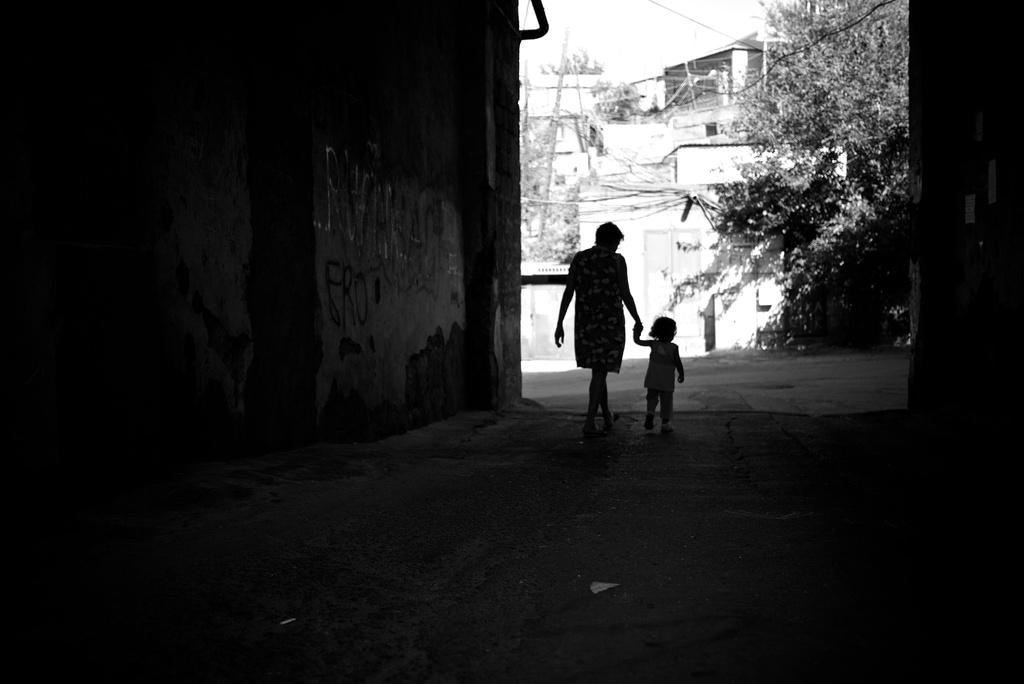Who is the main subject in the image? There is a lady in the image. What is the lady doing in the image? The lady is holding the hand of a baby and walking. What can be seen in the background of the image? There are buildings and trees in the background of the image. How is the foreground of the image described? The foreground of the image is dark. What type of desk is visible in the image? There is no desk present in the image. What month is it in the image? The image does not provide information about the month. 